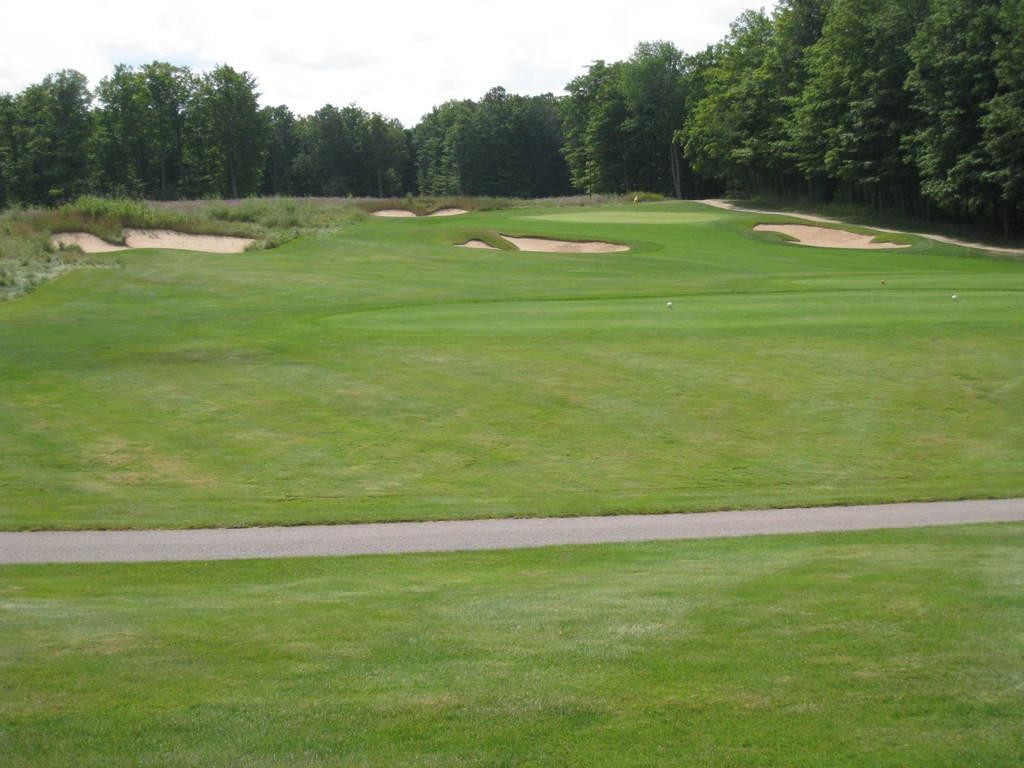How would you summarize this image in a sentence or two? In the foreground of this image, there is a golf court, grass and path. Trees and the sky are on the top. 